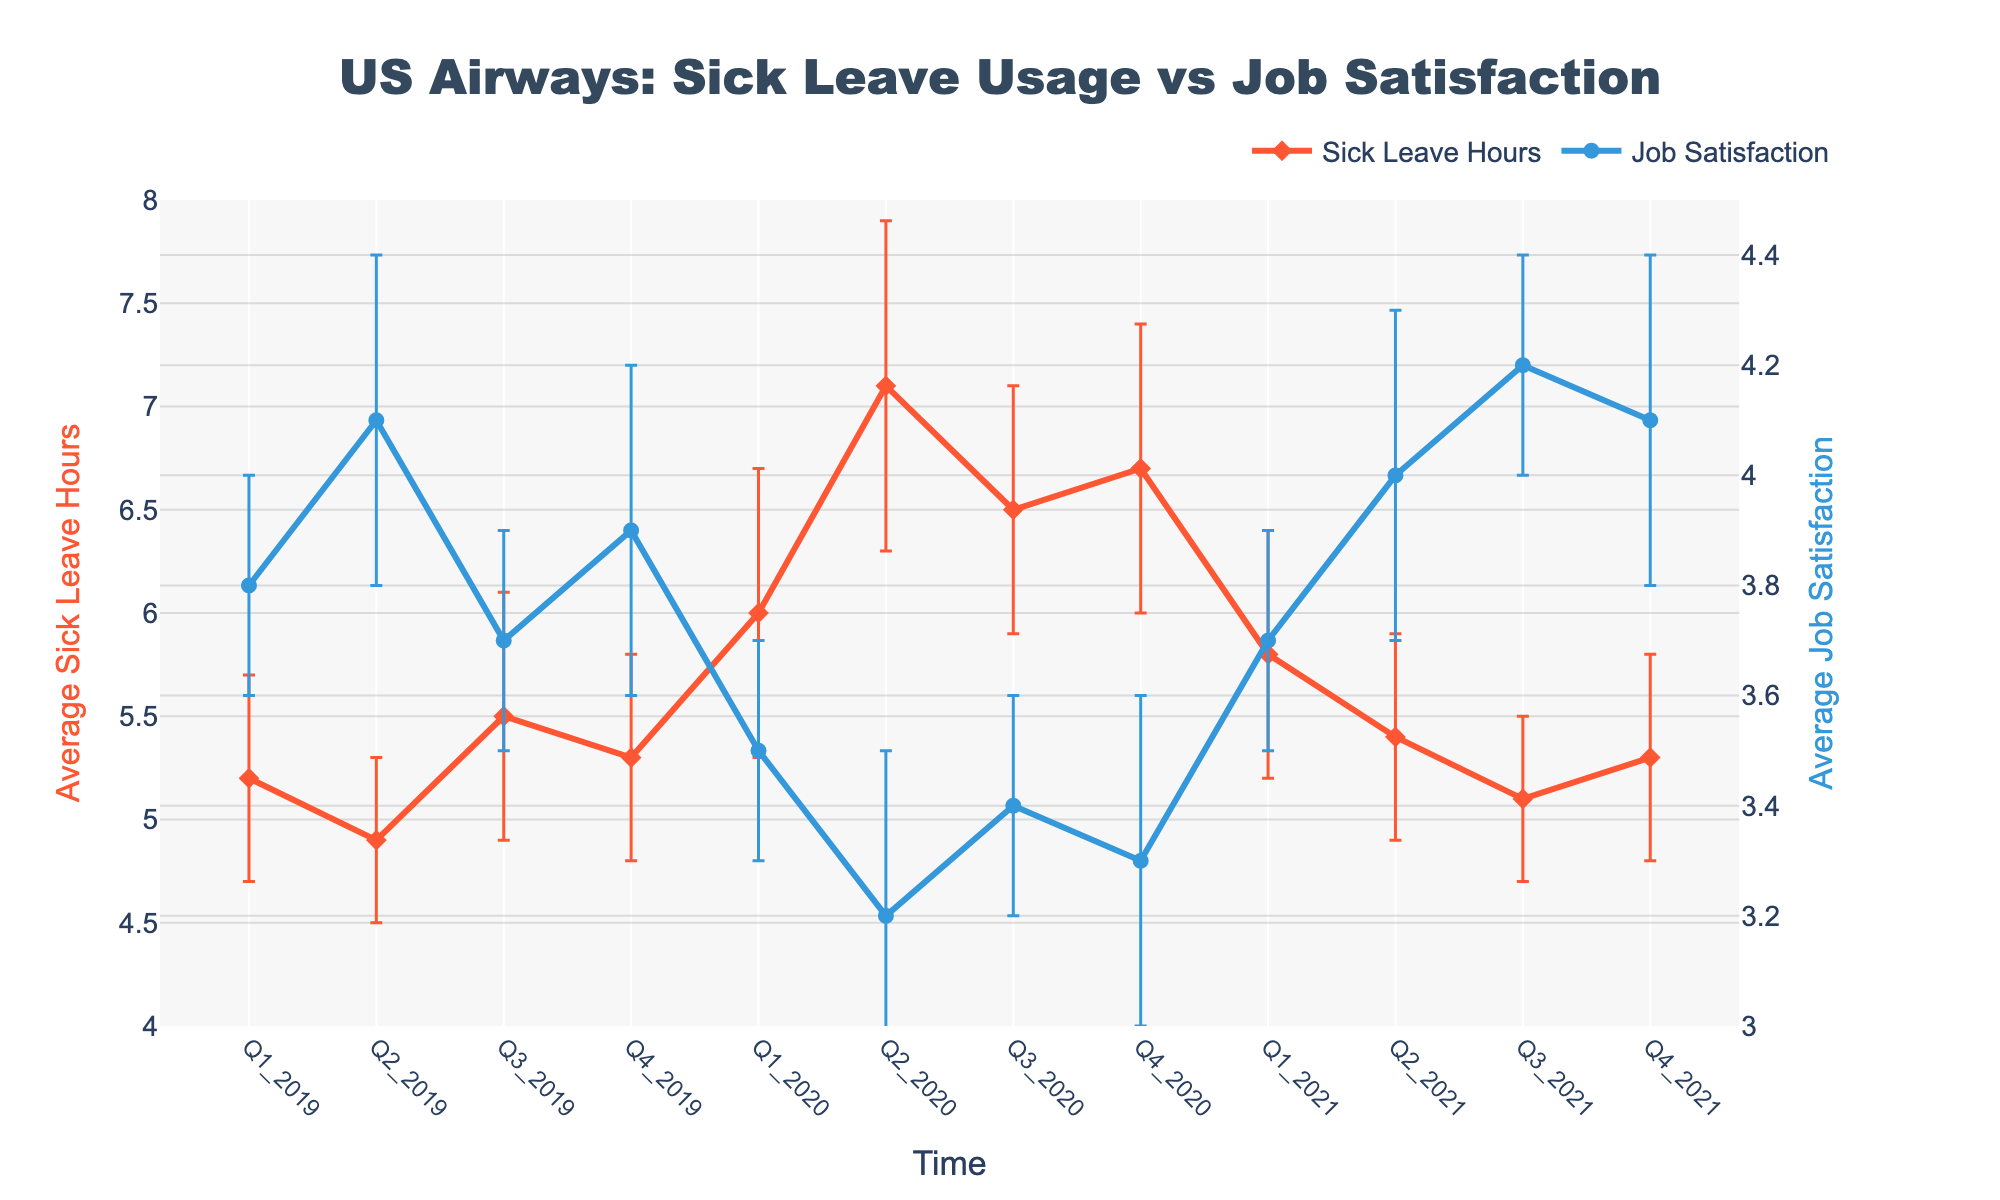What is the title of the figure? The title of the figure is displayed prominently at the top, indicating what the figure represents. It reads "US Airways: Sick Leave Usage vs Job Satisfaction".
Answer: US Airways: Sick Leave Usage vs Job Satisfaction Which variable shows mean sick leave hours? The variable "mean sick leave hours" is shown on the left vertical axis, with data points plotted in orange color along the quarter intervals.
Answer: Sick Leave Hours What is the value of mean job satisfaction in Q2_2019? The line plot shows mean job satisfaction for each quarter with blue markers. For Q2_2019, the marker shows a value of 4.1.
Answer: 4.1 How does the mean sick leave hours in Q2_2020 compare to Q4_2019? In Q2_2020, the mean sick leave hours is 7.1, while in Q4_2019 it is 5.3, indicating that the sick leave hours increased from Q4_2019 to Q2_2020.
Answer: Increased What is the range of the y-axis for job satisfaction? The range of the job satisfaction y-axis is determined by the gridlines, which shows a minimum value of 3.0 and a maximum value of 4.5.
Answer: 3 to 4.5 What is the highest mean job satisfaction observed and in which quarter? Scanning the line plot for job satisfaction, the highest value is 4.2, which occurs in Q3_2021.
Answer: 4.2 in Q3_2021 Which quarter had the highest mean sick leave hours and what was the value? The line plot for sick leave hours shows the peak at Q2_2020 with a value of 7.1 hours.
Answer: Q2_2020, 7.1 hours How does job satisfaction appear to change in relation to sick leave between Q1_2020 and Q2_2020? Between Q1_2020 and Q2_2020, sick leave hours increased from 6.0 to 7.1, and job satisfaction decreased from 3.5 to 3.2, suggesting an inverse relationship during this period.
Answer: Inversely related What were the mean sick leave hours in Q1_2020 and Q1_2021, and how did they change? The mean sick leave hours were 6.0 in Q1_2020 and 5.8 in Q1_2021, indicating a slight decrease of 0.2 hours over this one-year period.
Answer: Decreased by 0.2 hours Based on the error bars, which quarter has the least variability in job satisfaction? The error bars depict the standard error for job satisfaction. Q1_2019 has the shortest error bars, indicating the least variability.
Answer: Q1_2019 